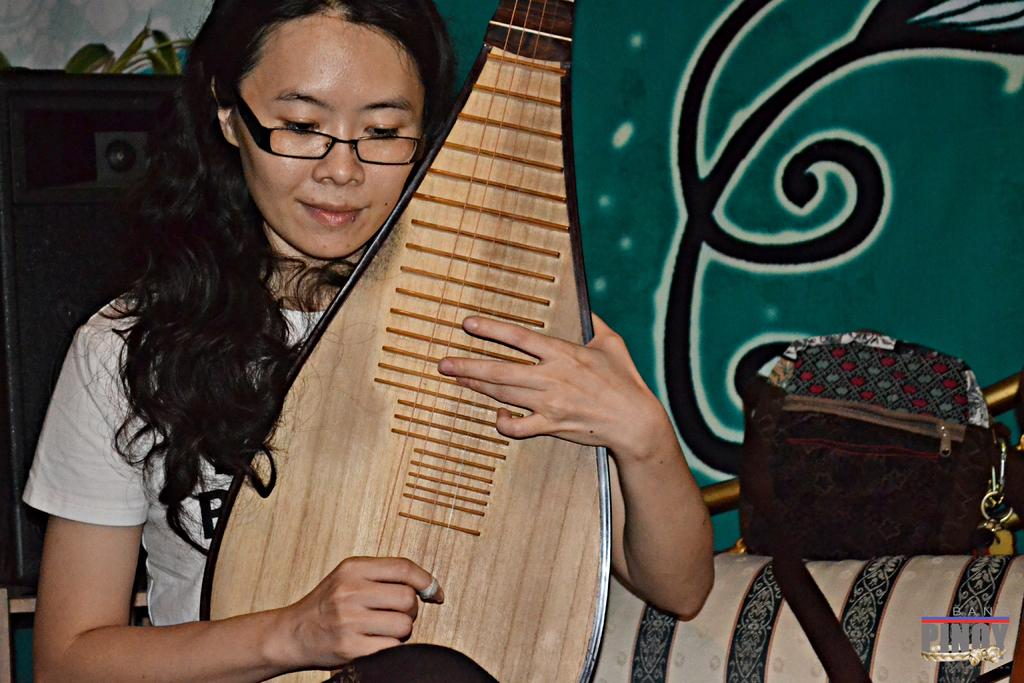Who is the main subject in the image? There is a woman in the image. What is the woman holding in the image? The woman is holding a guitar. What can be seen in the background of the image? There is a wall in the background of the image. How many boats are visible in the image? There are no boats present in the image. What type of arithmetic problem is the woman solving in the image? There is no arithmetic problem visible in the image; the woman is holding a guitar. 